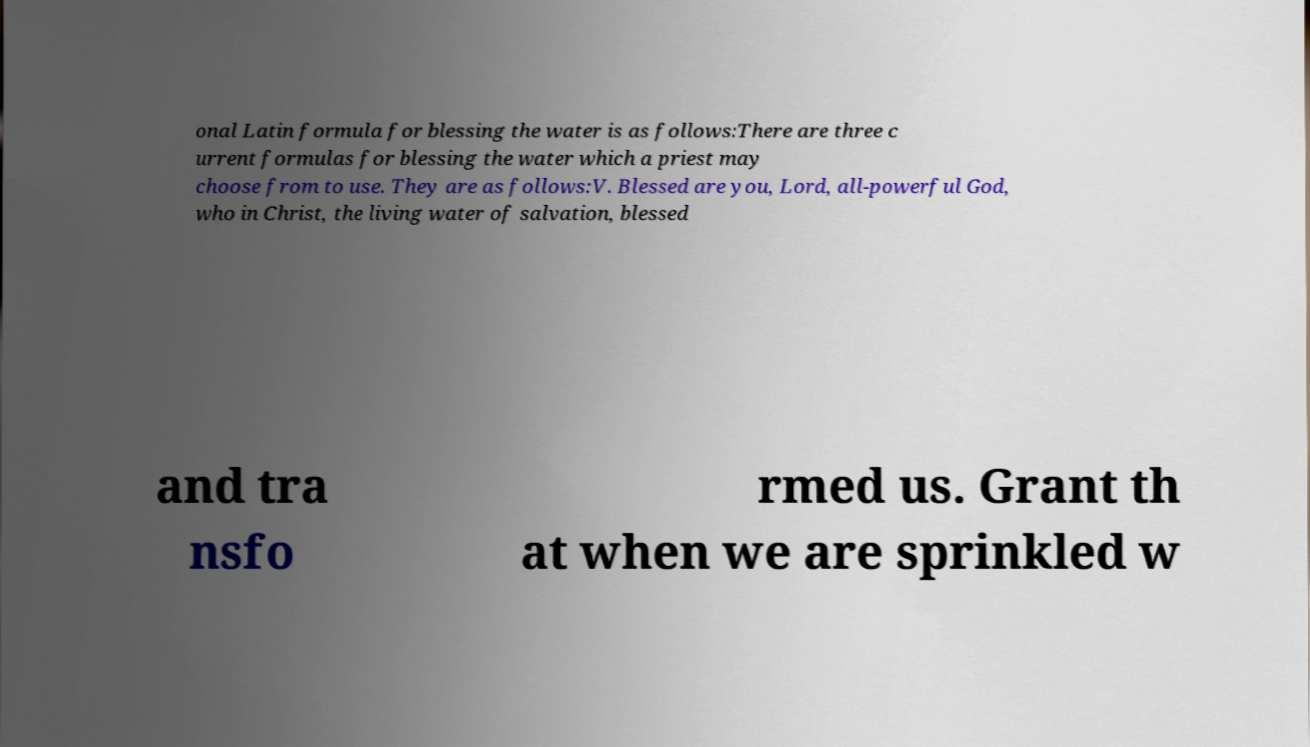Please read and relay the text visible in this image. What does it say? onal Latin formula for blessing the water is as follows:There are three c urrent formulas for blessing the water which a priest may choose from to use. They are as follows:V. Blessed are you, Lord, all-powerful God, who in Christ, the living water of salvation, blessed and tra nsfo rmed us. Grant th at when we are sprinkled w 